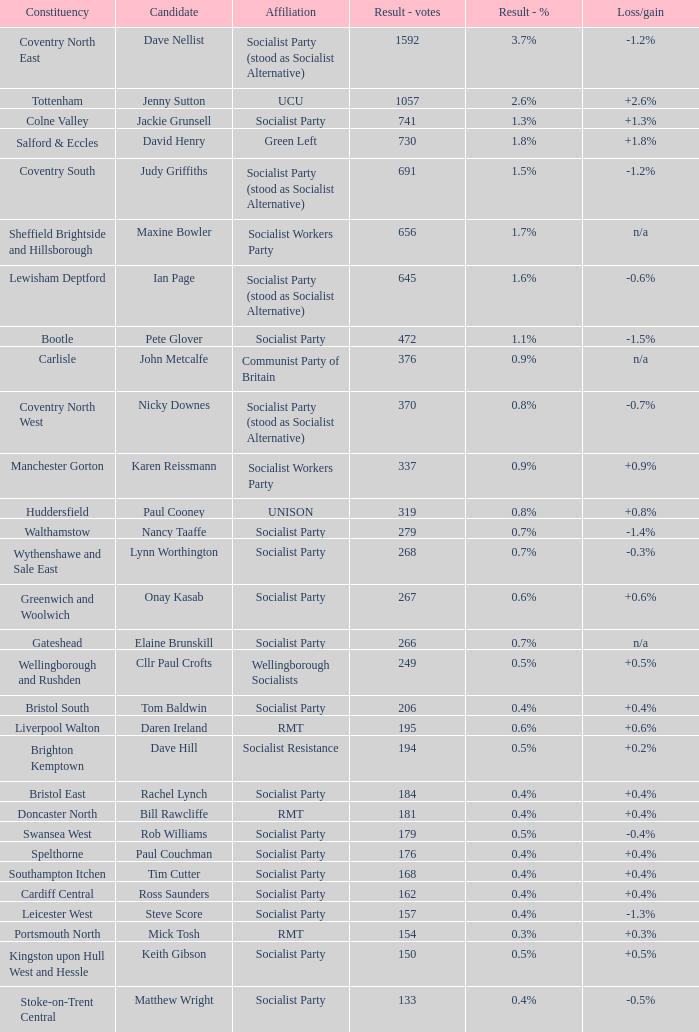How many values for constituency for the vote result of 162? 1.0. 